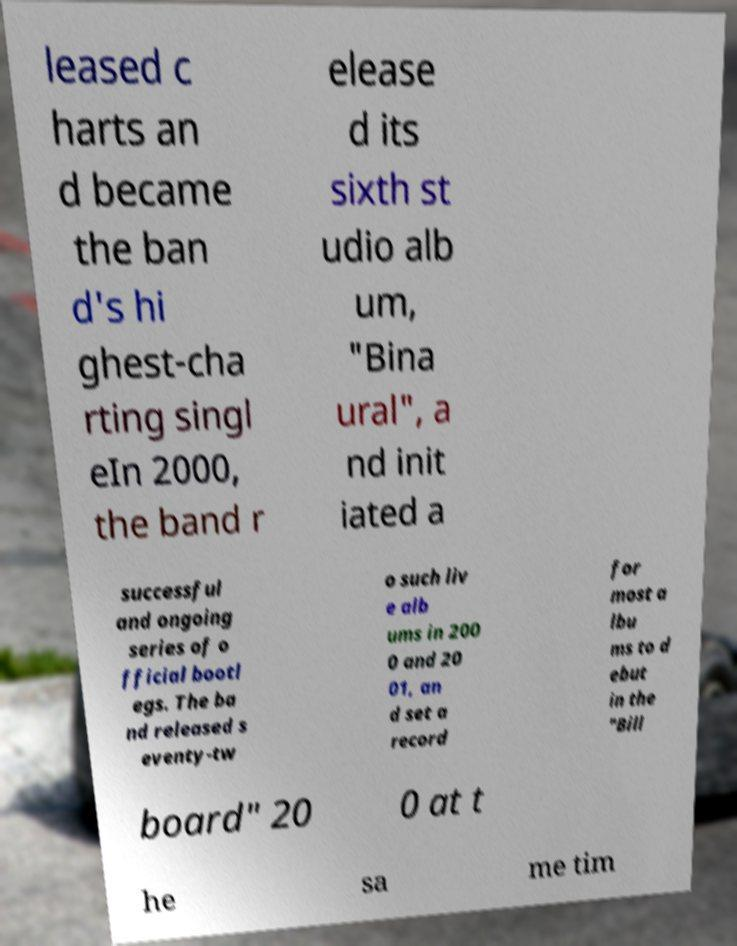Could you assist in decoding the text presented in this image and type it out clearly? leased c harts an d became the ban d's hi ghest-cha rting singl eIn 2000, the band r elease d its sixth st udio alb um, "Bina ural", a nd init iated a successful and ongoing series of o fficial bootl egs. The ba nd released s eventy-tw o such liv e alb ums in 200 0 and 20 01, an d set a record for most a lbu ms to d ebut in the "Bill board" 20 0 at t he sa me tim 